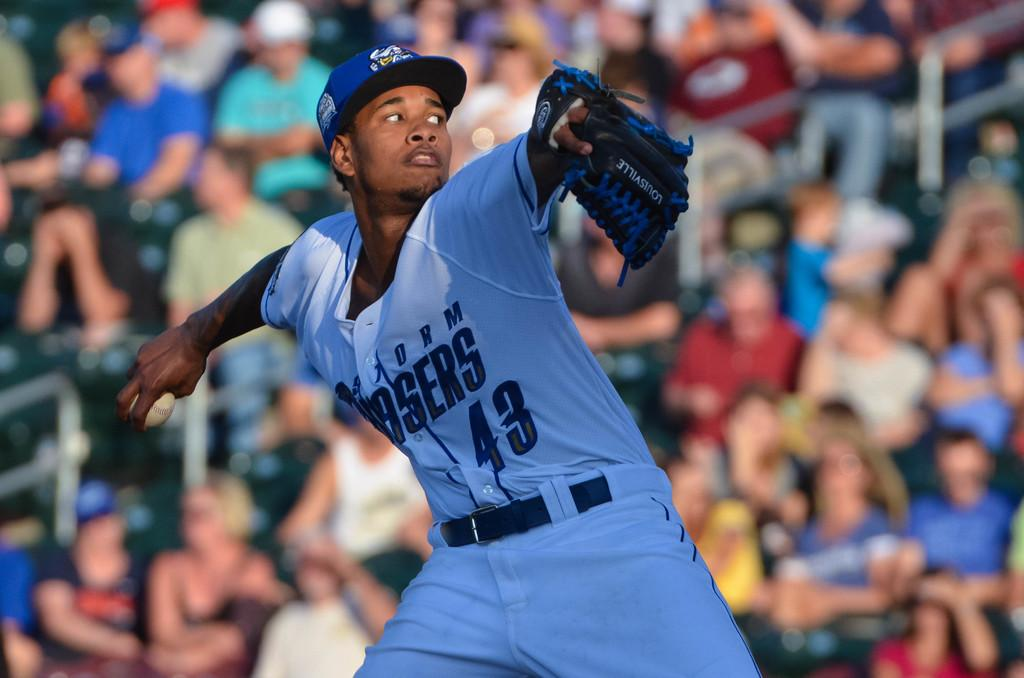<image>
Relay a brief, clear account of the picture shown. A baseball player numbered 43 is pitching a ball. 